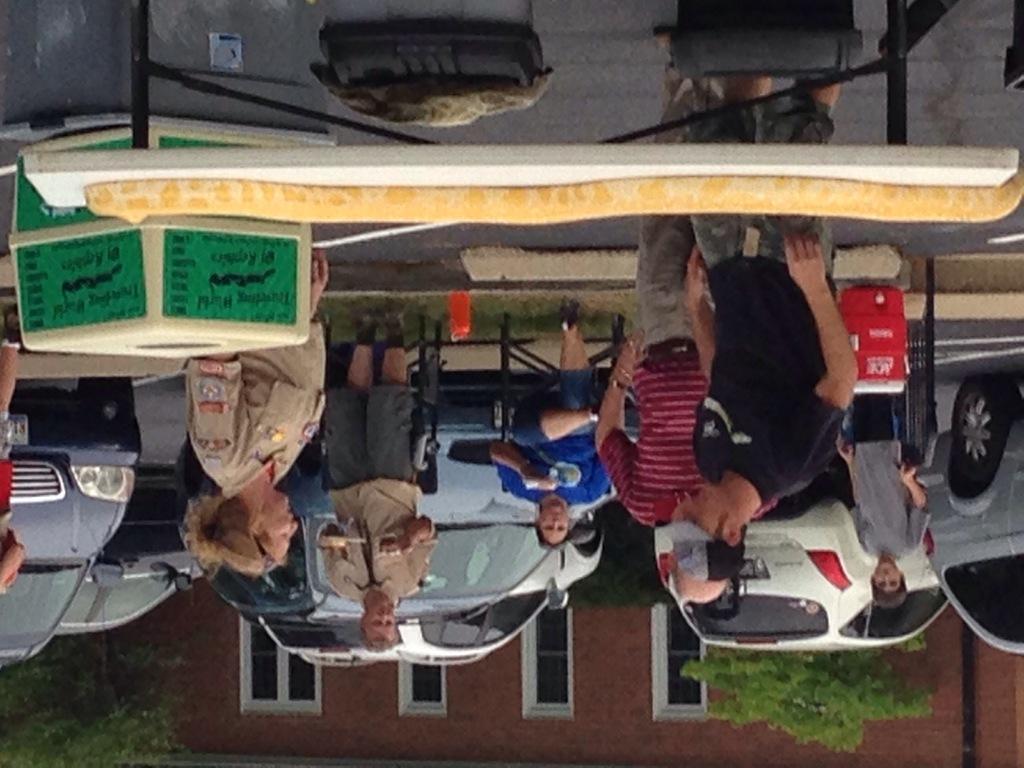In one or two sentences, can you explain what this image depicts? At the top, I can see a table and some objects. In the middle, I can see vehicles and a group of people on the road. In the background, I can see a building, trees and windows. This picture might be taken in a day. 